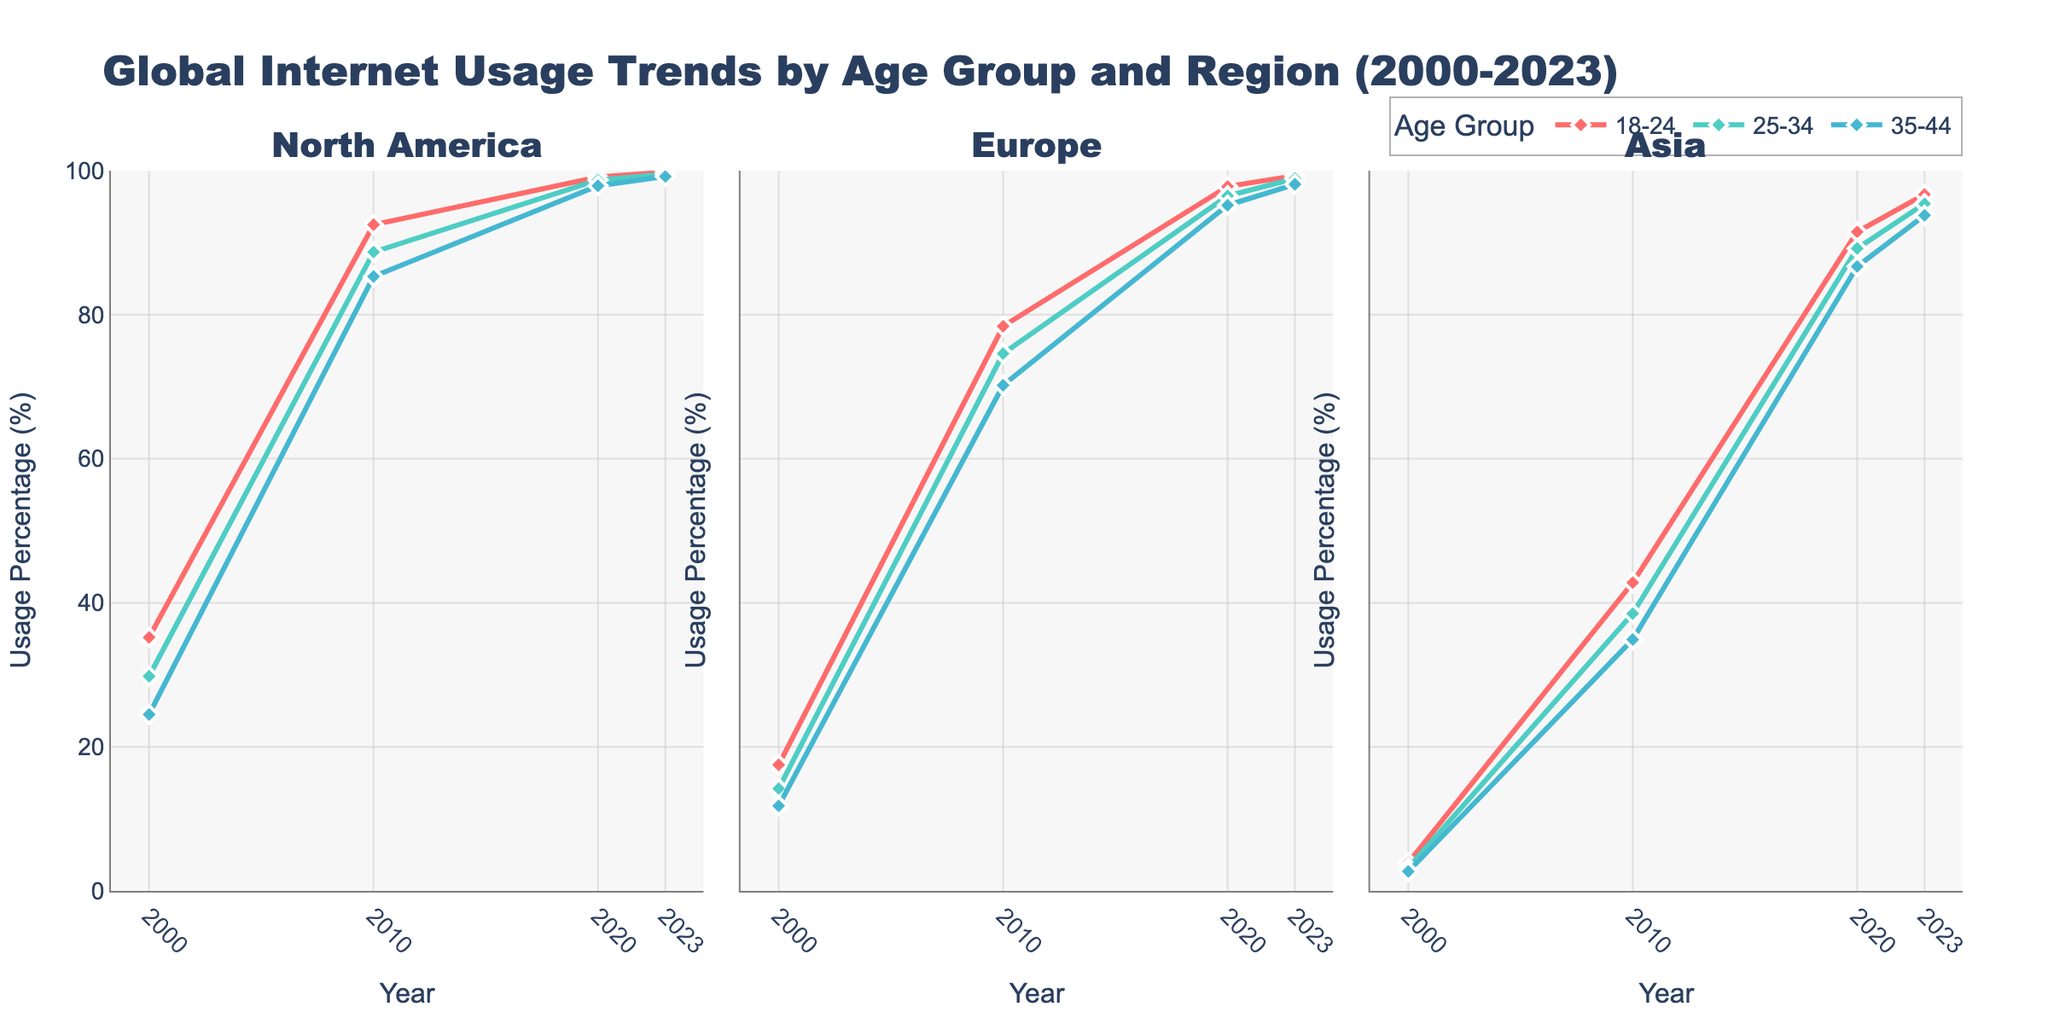What's the title of the figure? The title is usually displayed at the top of the figure. In this case, it reads "Global Internet Usage Trends by Age Group and Region (2000-2023)"
Answer: Global Internet Usage Trends by Age Group and Region (2000-2023) What regions are represented in the figure? The subplot titles usually indicate the regions. Here, the regions are North America, Europe, and Asia.
Answer: North America, Europe, Asia What are the age groups represented in the line charts? The legend typically shows the different age groups. Here, the age groups are 18-24, 25-34, and 35-44
Answer: 18-24, 25-34, 35-44 What color represents the 25-34 age group in the figure? The line color for each age group can be seen in the legend. The 25-34 age group is represented by a specific color.
Answer: turquoise In which year did the 18-24 age group in North America reach near-total internet usage? Looking at the plot for North America, observe when the 18-24 age group approaches 100%. This occurs around 2020.
Answer: 2020 By how many percentage points did internet usage among the 18-24 age group in Asia increase from 2000 to 2010? Subtract the 2000 value from the 2010 value for the 18-24 age group in Asia. This is calculated as (42.8 - 3.9).
Answer: 38.9 Which region showed the greatest increase in internet usage for the 35-44 age group from 2000 to 2023? Calculate the increase for each region by subtracting the 2000 value from the 2023 value for the 35-44 age group. Compare the results.
Answer: Asia (91.1 percentage points increase) Is the internet usage percentage for the 25-34 age group higher in Europe or North America in 2023? Compare the data points on the plots for Europe and North America in 2023 for the 25-34 age group. North America shows a slightly higher value than Europe.
Answer: North America In what year did the 18-24 age group in Europe surpass 90% internet usage? Check the Europe subplot for the 18-24 age group and find the year where the line crosses above 90%. This happens around 2020.
Answer: 2020 Which age group in Asia showed the least internet usage increase from 2010 to 2023? Subtract the 2010 values from the 2023 values for each age group in Asia and compare the differences. The 35-44 age group has the smallest increase.
Answer: 35-44 